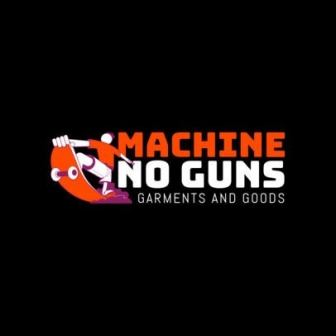Can you describe what the character in the logo is doing? The character in the logo appears to be holding a machine gun. However, the gun is covered by a red circle with a line through it, symbolizing that guns are not allowed. This design effectively communicates the company's name and mission. What does the red circle with a line through it signify? The red circle with a line through it is a universal symbol indicating prohibition or 'not allowed'. In this context, it signifies that the use of guns is strictly prohibited, reinforcing the company’s name 'Machine No Guns' and its anti-gun stance. 